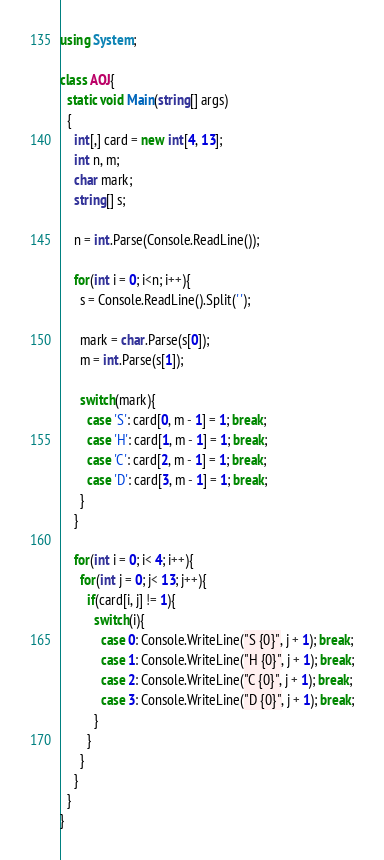<code> <loc_0><loc_0><loc_500><loc_500><_C#_>using System;

class AOJ{
  static void Main(string[] args)
  {
    int[,] card = new int[4, 13];
    int n, m;
    char mark;
    string[] s;

    n = int.Parse(Console.ReadLine());

    for(int i = 0; i<n; i++){
      s = Console.ReadLine().Split(' ');

      mark = char.Parse(s[0]);
      m = int.Parse(s[1]);

      switch(mark){
        case 'S': card[0, m - 1] = 1; break;
        case 'H': card[1, m - 1] = 1; break;
        case 'C': card[2, m - 1] = 1; break;
        case 'D': card[3, m - 1] = 1; break;
      }
    }

    for(int i = 0; i< 4; i++){
      for(int j = 0; j< 13; j++){
        if(card[i, j] != 1){
          switch(i){
            case 0: Console.WriteLine("S {0}", j + 1); break;
            case 1: Console.WriteLine("H {0}", j + 1); break;
            case 2: Console.WriteLine("C {0}", j + 1); break;
            case 3: Console.WriteLine("D {0}", j + 1); break;
          }
        }
      }
    }
  }
}</code> 